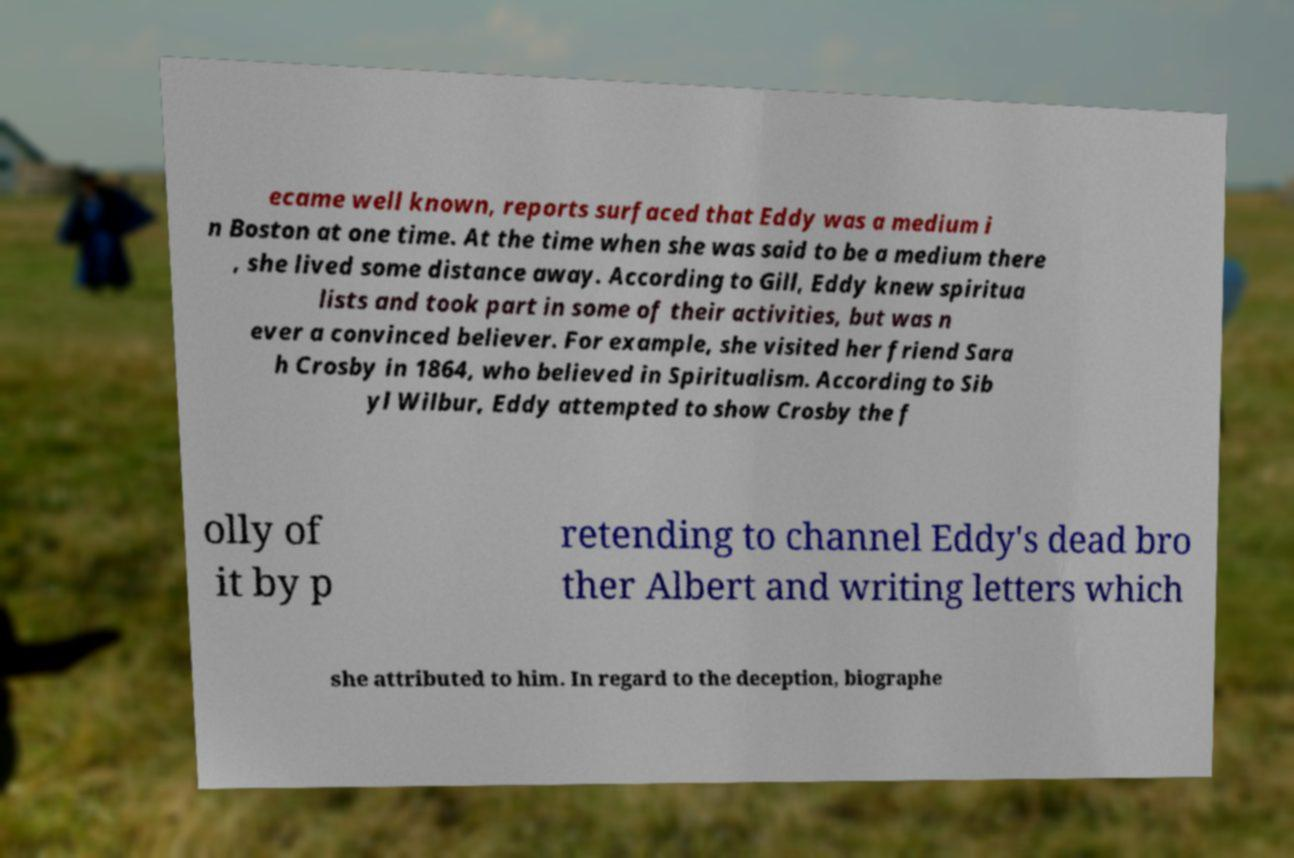Please read and relay the text visible in this image. What does it say? ecame well known, reports surfaced that Eddy was a medium i n Boston at one time. At the time when she was said to be a medium there , she lived some distance away. According to Gill, Eddy knew spiritua lists and took part in some of their activities, but was n ever a convinced believer. For example, she visited her friend Sara h Crosby in 1864, who believed in Spiritualism. According to Sib yl Wilbur, Eddy attempted to show Crosby the f olly of it by p retending to channel Eddy's dead bro ther Albert and writing letters which she attributed to him. In regard to the deception, biographe 